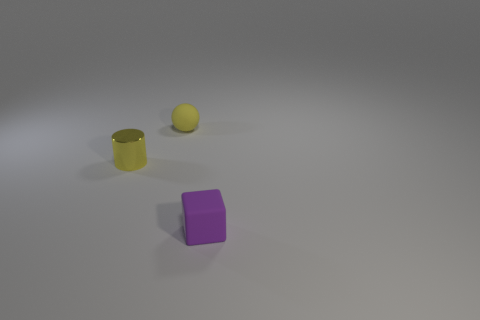Add 2 red matte cubes. How many objects exist? 5 Subtract all blue cubes. Subtract all purple balls. How many cubes are left? 1 Subtract all metal cylinders. Subtract all purple matte objects. How many objects are left? 1 Add 1 yellow metal objects. How many yellow metal objects are left? 2 Add 1 small rubber spheres. How many small rubber spheres exist? 2 Subtract 0 brown balls. How many objects are left? 3 Subtract all cubes. How many objects are left? 2 Subtract 1 cubes. How many cubes are left? 0 